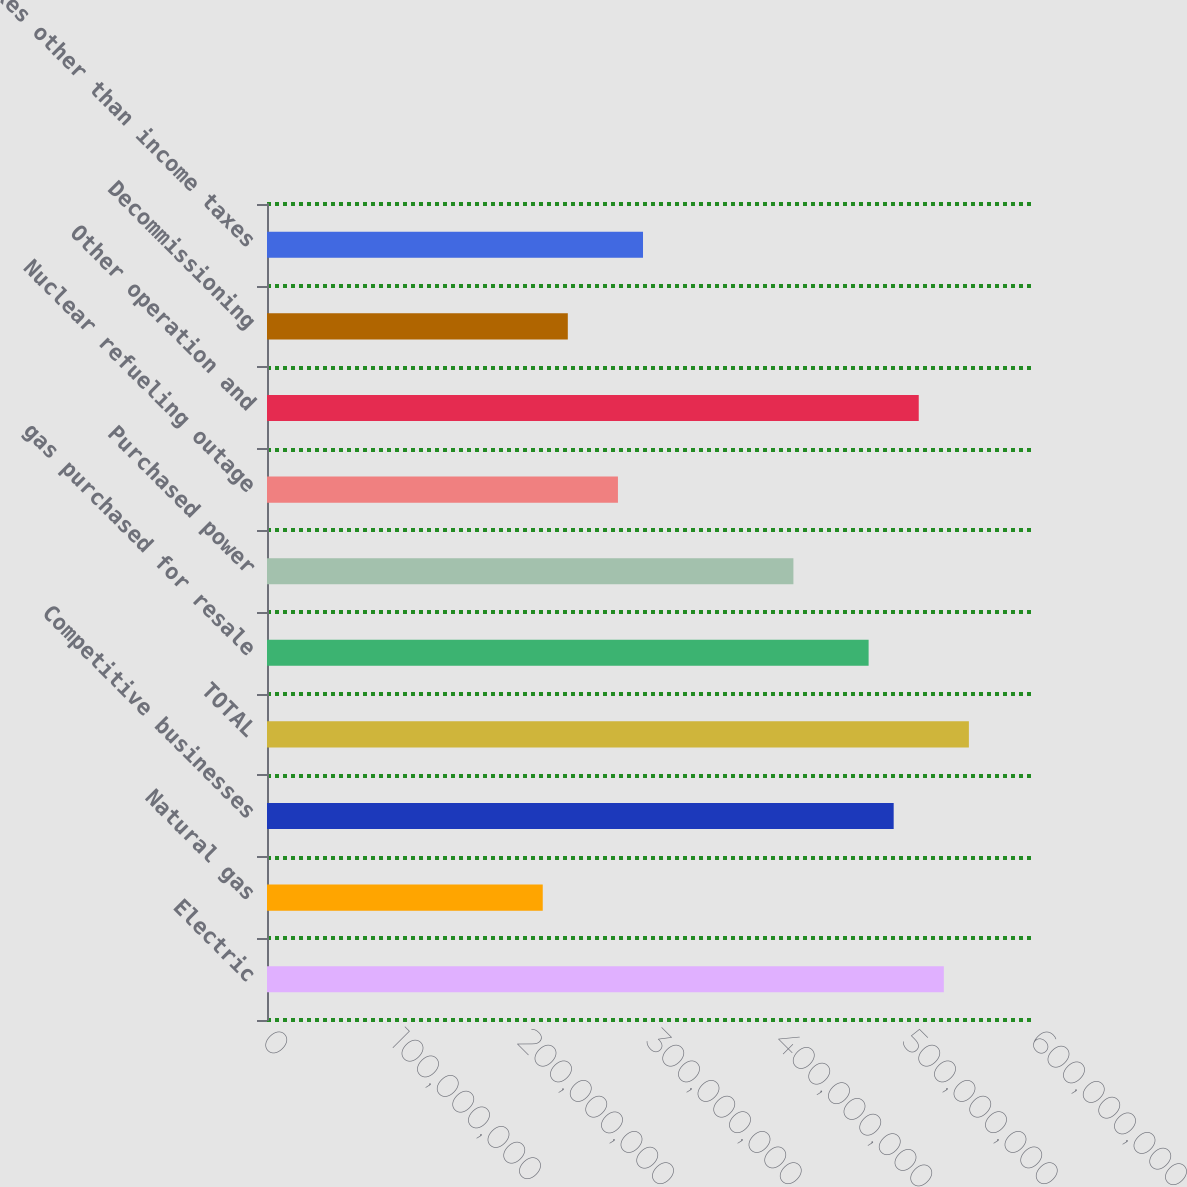Convert chart. <chart><loc_0><loc_0><loc_500><loc_500><bar_chart><fcel>Electric<fcel>Natural gas<fcel>Competitive businesses<fcel>TOTAL<fcel>gas purchased for resale<fcel>Purchased power<fcel>Nuclear refueling outage<fcel>Other operation and<fcel>Decommissioning<fcel>Taxes other than income taxes<nl><fcel>5.28763e+08<fcel>2.15422e+08<fcel>4.89595e+08<fcel>5.48347e+08<fcel>4.70011e+08<fcel>4.1126e+08<fcel>2.74173e+08<fcel>5.09179e+08<fcel>2.35006e+08<fcel>2.93757e+08<nl></chart> 